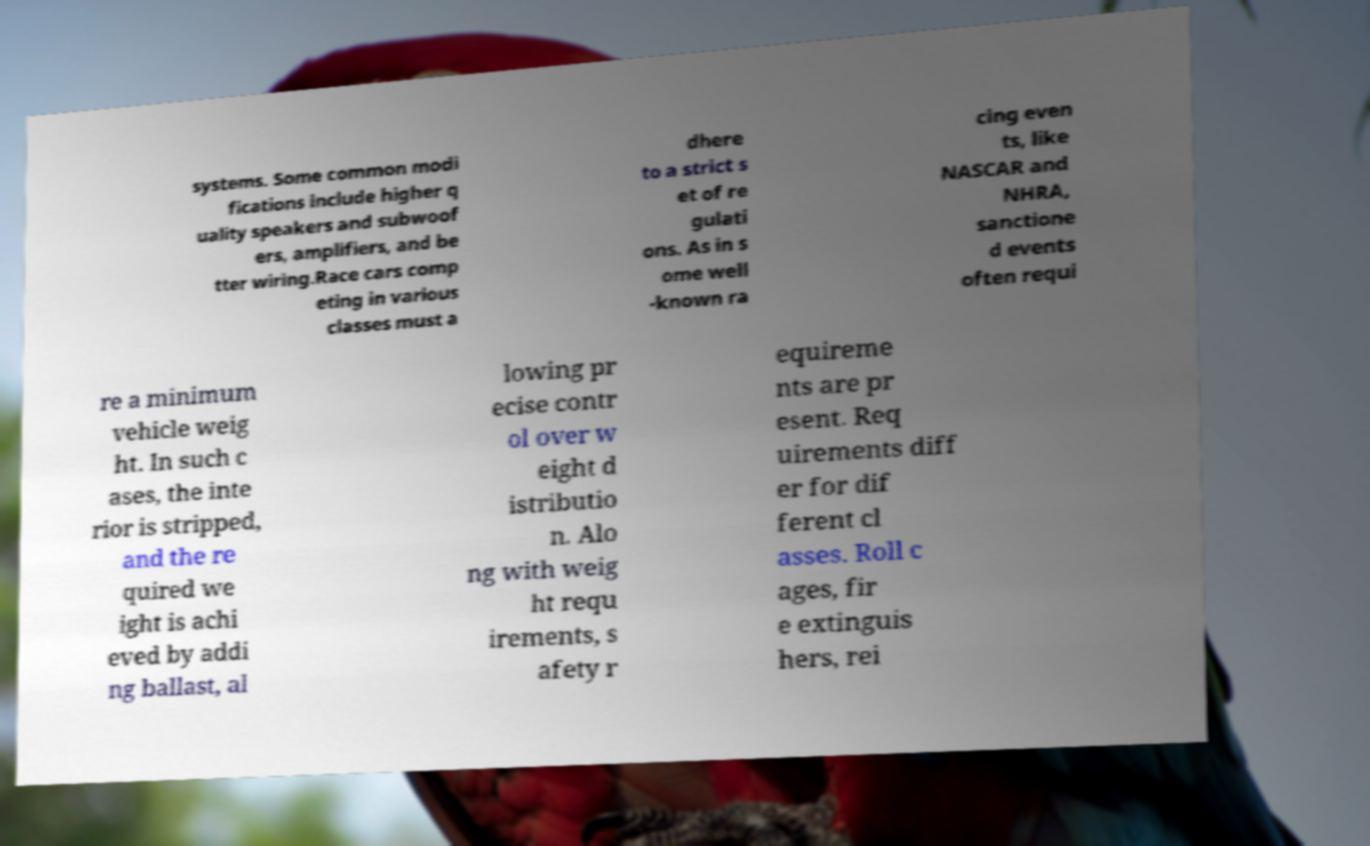What messages or text are displayed in this image? I need them in a readable, typed format. systems. Some common modi fications include higher q uality speakers and subwoof ers, amplifiers, and be tter wiring.Race cars comp eting in various classes must a dhere to a strict s et of re gulati ons. As in s ome well -known ra cing even ts, like NASCAR and NHRA, sanctione d events often requi re a minimum vehicle weig ht. In such c ases, the inte rior is stripped, and the re quired we ight is achi eved by addi ng ballast, al lowing pr ecise contr ol over w eight d istributio n. Alo ng with weig ht requ irements, s afety r equireme nts are pr esent. Req uirements diff er for dif ferent cl asses. Roll c ages, fir e extinguis hers, rei 